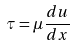<formula> <loc_0><loc_0><loc_500><loc_500>\tau = \mu \frac { d u } { d x }</formula> 